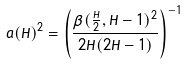<formula> <loc_0><loc_0><loc_500><loc_500>a ( H ) ^ { 2 } = \left ( \frac { \beta ( \frac { H } { 2 } , H - 1 ) ^ { 2 } } { 2 H ( 2 H - 1 ) } \right ) ^ { - 1 }</formula> 